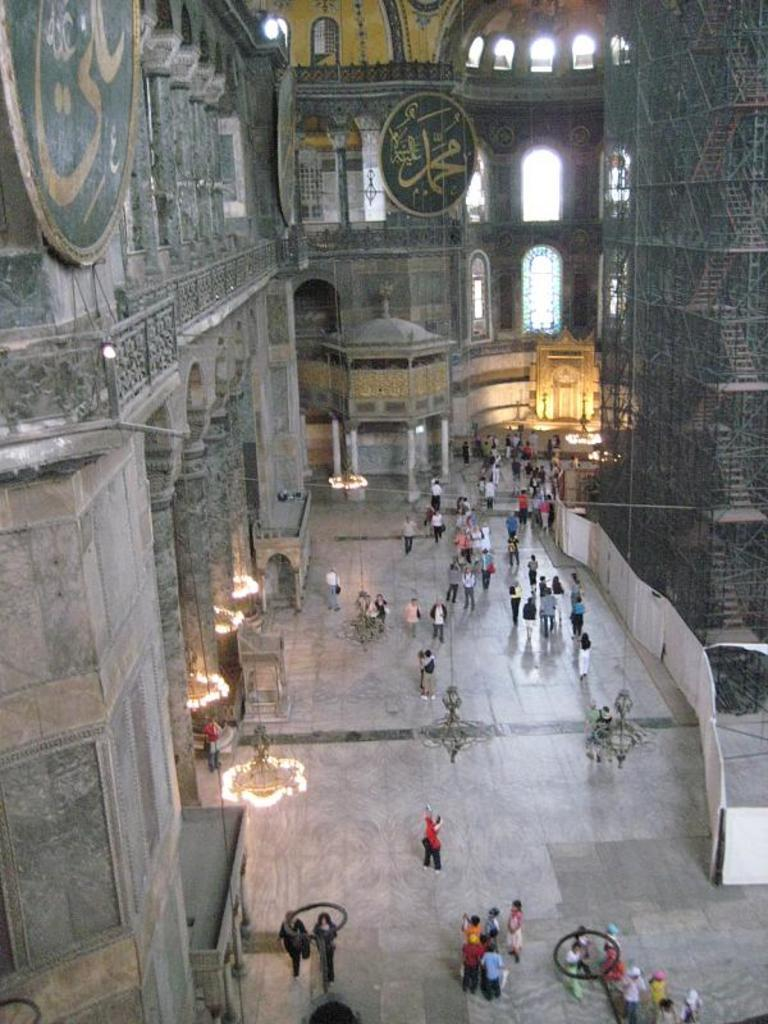What are the people in the image doing? The people in the image are on the floor. What can be seen hanging from the roof in the image? There are lights hanging from the roof in the image. What is visible on the wall in the background of the image? There is a wall with boards attached to it in the background of the image. What type of battle is taking place in the image? There is no battle present in the image; it features people on the floor and lights hanging from the roof. How does the image demand the viewer's attention? The image does not actively demand the viewer's attention; it simply presents the scene as it is. 